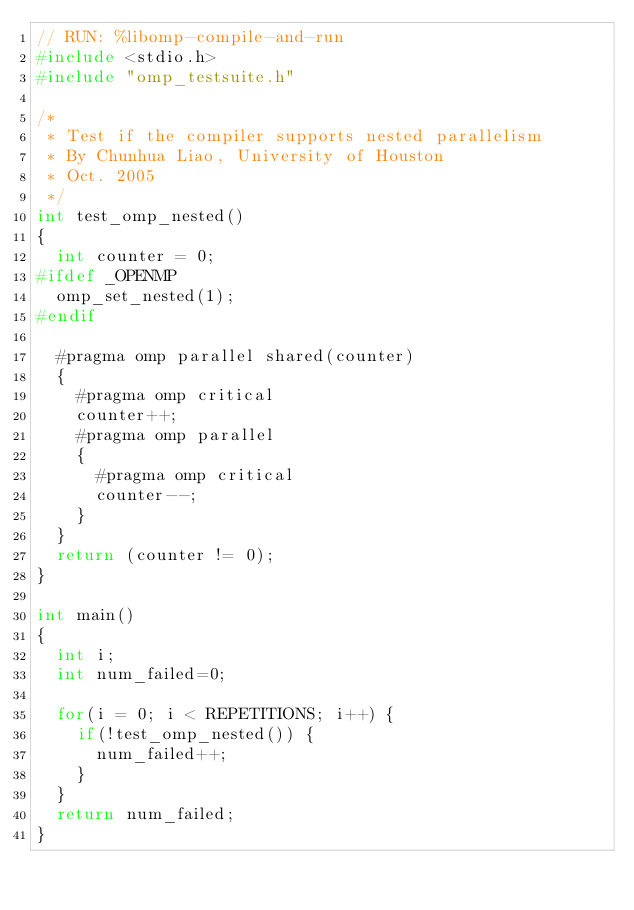<code> <loc_0><loc_0><loc_500><loc_500><_C_>// RUN: %libomp-compile-and-run
#include <stdio.h>
#include "omp_testsuite.h"

/*
 * Test if the compiler supports nested parallelism
 * By Chunhua Liao, University of Houston
 * Oct. 2005
 */
int test_omp_nested()
{
  int counter = 0;
#ifdef _OPENMP
  omp_set_nested(1);
#endif

  #pragma omp parallel shared(counter)
  {
    #pragma omp critical
    counter++;
    #pragma omp parallel
    {
      #pragma omp critical
      counter--;
    }
  }
  return (counter != 0);
}

int main()
{
  int i;
  int num_failed=0;

  for(i = 0; i < REPETITIONS; i++) {
    if(!test_omp_nested()) {
      num_failed++;
    }
  }
  return num_failed;
}
</code> 